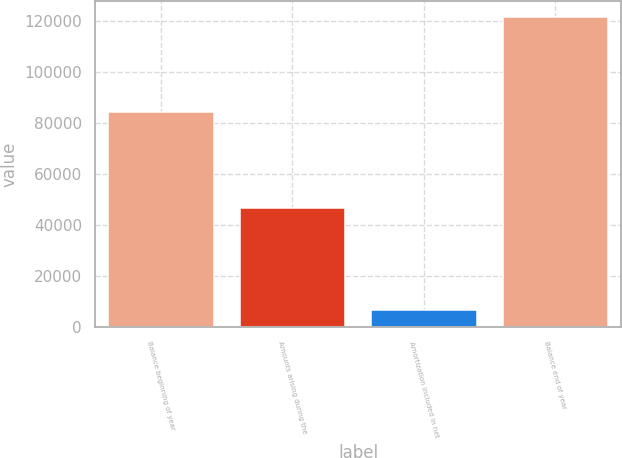<chart> <loc_0><loc_0><loc_500><loc_500><bar_chart><fcel>Balance beginning of year<fcel>Amounts arising during the<fcel>Amortization included in net<fcel>Balance end of year<nl><fcel>84122<fcel>46580<fcel>6670<fcel>121522<nl></chart> 